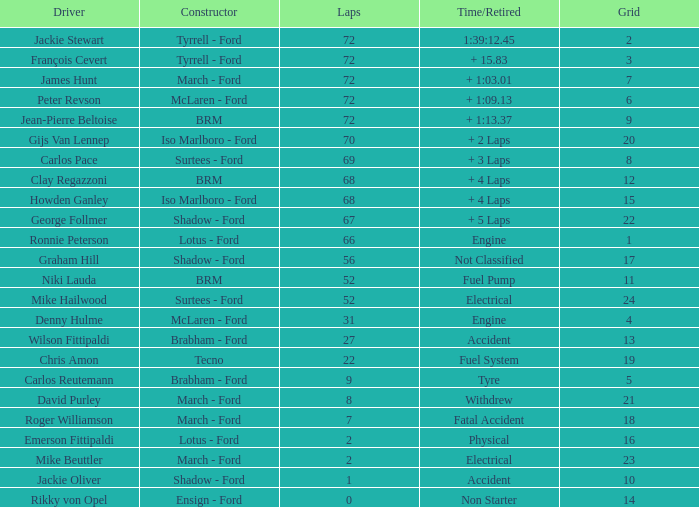What is the top grid that laps less than 66 and a retried engine? 4.0. 